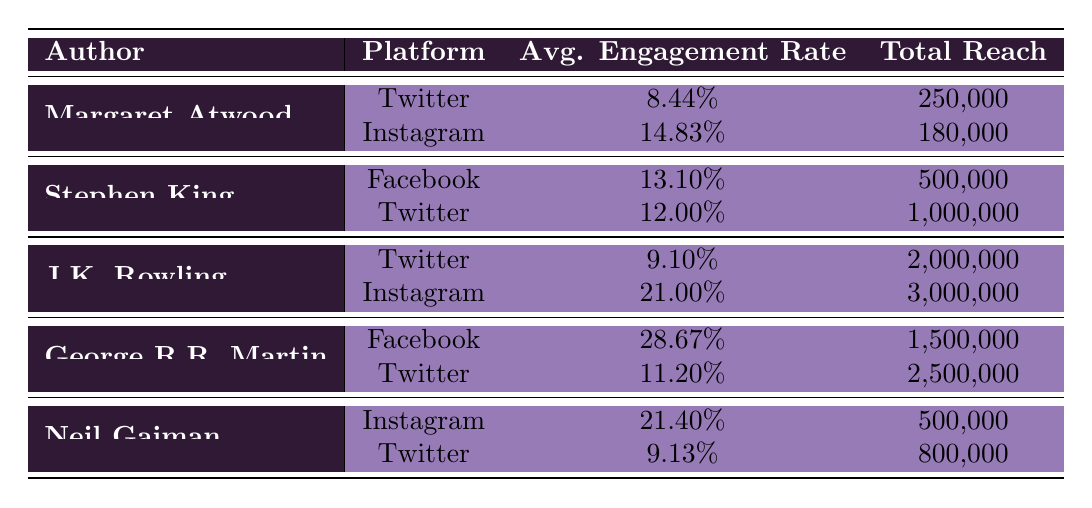What is the average engagement rate for J.K. Rowling across both platforms? To find the average engagement rate for J.K. Rowling, we add the engagement rates from both platforms: 9.10% (Twitter) + 21.00% (Instagram) = 30.10%. Then, we divide by 2 to find the average: 30.10% / 2 = 15.05%.
Answer: 15.05% Which author has the highest total reach? By comparing the total reach of each author, we see that J.K. Rowling has a total reach of 3,000,000 (Instagram), which is greater than any other author listed.
Answer: J.K. Rowling Does Stephen King have a higher engagement rate on Facebook than on Twitter? To determine this, we compare the engagement rates: Stephen King's engagement rate on Facebook is 13.10%, while on Twitter, it is 12.00%. Since 13.10% > 12.00%, the statement is true.
Answer: Yes What is the total reach for George R.R. Martin across both platforms? We need to sum the total reach across both platforms for George R.R. Martin: 1,500,000 (Facebook) + 2,500,000 (Twitter) = 4,000,000.
Answer: 4,000,000 Is Neil Gaiman's engagement rate on Instagram higher than that of Margaret Atwood on Twitter? Neil Gaiman's engagement rate on Instagram is 21.40%, while Margaret Atwood's engagement rate on Twitter is 8.44%. Since 21.40% > 8.44%, the statement is true.
Answer: Yes 